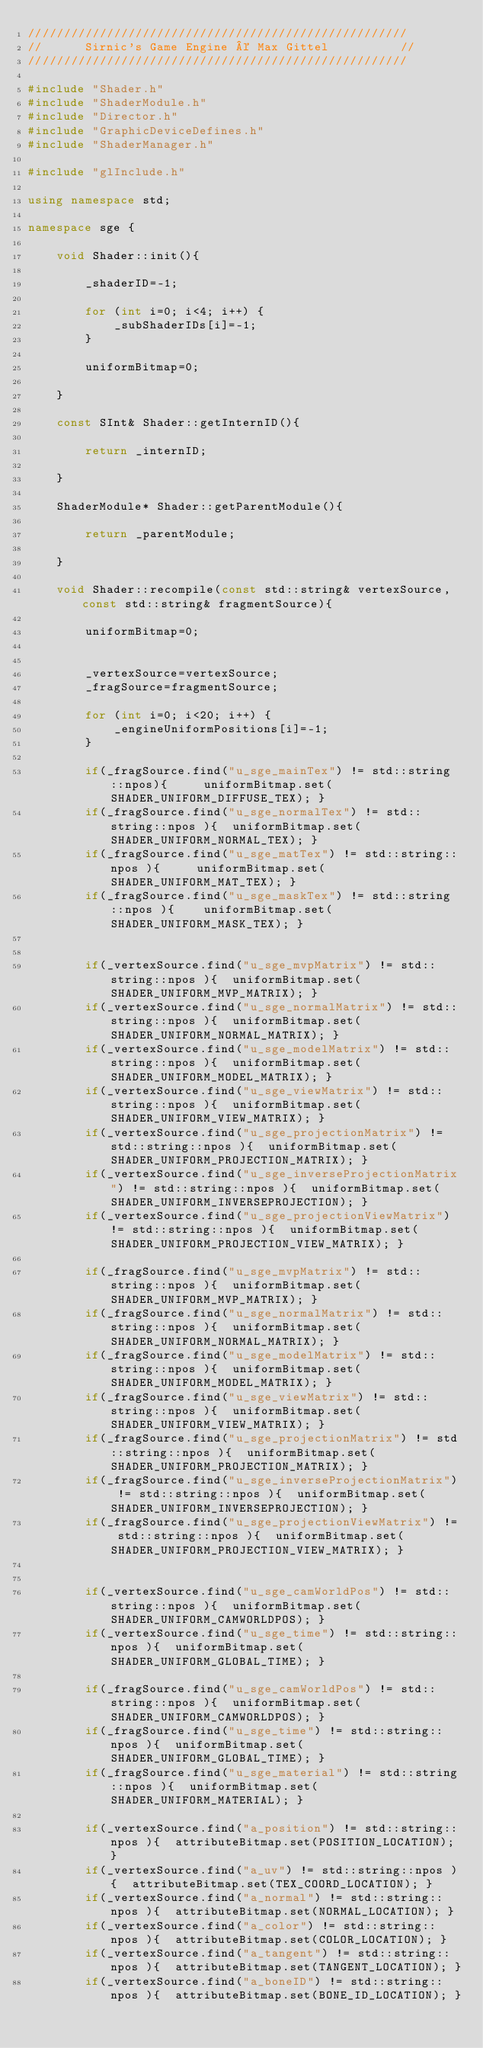<code> <loc_0><loc_0><loc_500><loc_500><_C++_>/////////////////////////////////////////////////////
//      Sirnic's Game Engine © Max Gittel          //
/////////////////////////////////////////////////////

#include "Shader.h"
#include "ShaderModule.h"
#include "Director.h"
#include "GraphicDeviceDefines.h"
#include "ShaderManager.h"

#include "glInclude.h"

using namespace std;

namespace sge {
    
    void Shader::init(){
    
        _shaderID=-1;
       
        for (int i=0; i<4; i++) {
            _subShaderIDs[i]=-1;
        }
        
        uniformBitmap=0;

    }
    
    const SInt& Shader::getInternID(){
    
        return _internID;
    
    }
    
    ShaderModule* Shader::getParentModule(){
    
        return _parentModule;
    
    }
    
    void Shader::recompile(const std::string& vertexSource, const std::string& fragmentSource){
    
        uniformBitmap=0;
        
        
        _vertexSource=vertexSource;
        _fragSource=fragmentSource;
        
        for (int i=0; i<20; i++) {
            _engineUniformPositions[i]=-1;
        }
        
        if(_fragSource.find("u_sge_mainTex") != std::string::npos){     uniformBitmap.set(SHADER_UNIFORM_DIFFUSE_TEX); }
        if(_fragSource.find("u_sge_normalTex") != std::string::npos ){  uniformBitmap.set(SHADER_UNIFORM_NORMAL_TEX); }
        if(_fragSource.find("u_sge_matTex") != std::string::npos ){     uniformBitmap.set(SHADER_UNIFORM_MAT_TEX); }
        if(_fragSource.find("u_sge_maskTex") != std::string::npos ){    uniformBitmap.set(SHADER_UNIFORM_MASK_TEX); }
        
        
        if(_vertexSource.find("u_sge_mvpMatrix") != std::string::npos ){  uniformBitmap.set(SHADER_UNIFORM_MVP_MATRIX); }
        if(_vertexSource.find("u_sge_normalMatrix") != std::string::npos ){  uniformBitmap.set(SHADER_UNIFORM_NORMAL_MATRIX); }
        if(_vertexSource.find("u_sge_modelMatrix") != std::string::npos ){  uniformBitmap.set(SHADER_UNIFORM_MODEL_MATRIX); }
        if(_vertexSource.find("u_sge_viewMatrix") != std::string::npos ){  uniformBitmap.set(SHADER_UNIFORM_VIEW_MATRIX); }
        if(_vertexSource.find("u_sge_projectionMatrix") != std::string::npos ){  uniformBitmap.set(SHADER_UNIFORM_PROJECTION_MATRIX); }
        if(_vertexSource.find("u_sge_inverseProjectionMatrix") != std::string::npos ){  uniformBitmap.set(SHADER_UNIFORM_INVERSEPROJECTION); }
        if(_vertexSource.find("u_sge_projectionViewMatrix") != std::string::npos ){  uniformBitmap.set(SHADER_UNIFORM_PROJECTION_VIEW_MATRIX); }
        
        if(_fragSource.find("u_sge_mvpMatrix") != std::string::npos ){  uniformBitmap.set(SHADER_UNIFORM_MVP_MATRIX); }
        if(_fragSource.find("u_sge_normalMatrix") != std::string::npos ){  uniformBitmap.set(SHADER_UNIFORM_NORMAL_MATRIX); }
        if(_fragSource.find("u_sge_modelMatrix") != std::string::npos ){  uniformBitmap.set(SHADER_UNIFORM_MODEL_MATRIX); }
        if(_fragSource.find("u_sge_viewMatrix") != std::string::npos ){  uniformBitmap.set(SHADER_UNIFORM_VIEW_MATRIX); }
        if(_fragSource.find("u_sge_projectionMatrix") != std::string::npos ){  uniformBitmap.set(SHADER_UNIFORM_PROJECTION_MATRIX); }
        if(_fragSource.find("u_sge_inverseProjectionMatrix") != std::string::npos ){  uniformBitmap.set(SHADER_UNIFORM_INVERSEPROJECTION); }
        if(_fragSource.find("u_sge_projectionViewMatrix") != std::string::npos ){  uniformBitmap.set(SHADER_UNIFORM_PROJECTION_VIEW_MATRIX); }
        
        
        if(_vertexSource.find("u_sge_camWorldPos") != std::string::npos ){  uniformBitmap.set(SHADER_UNIFORM_CAMWORLDPOS); }
        if(_vertexSource.find("u_sge_time") != std::string::npos ){  uniformBitmap.set(SHADER_UNIFORM_GLOBAL_TIME); }
        
        if(_fragSource.find("u_sge_camWorldPos") != std::string::npos ){  uniformBitmap.set(SHADER_UNIFORM_CAMWORLDPOS); }
        if(_fragSource.find("u_sge_time") != std::string::npos ){  uniformBitmap.set(SHADER_UNIFORM_GLOBAL_TIME); }
        if(_fragSource.find("u_sge_material") != std::string::npos ){  uniformBitmap.set(SHADER_UNIFORM_MATERIAL); }
        
        if(_vertexSource.find("a_position") != std::string::npos ){  attributeBitmap.set(POSITION_LOCATION); }
        if(_vertexSource.find("a_uv") != std::string::npos ){  attributeBitmap.set(TEX_COORD_LOCATION); }
        if(_vertexSource.find("a_normal") != std::string::npos ){  attributeBitmap.set(NORMAL_LOCATION); }
        if(_vertexSource.find("a_color") != std::string::npos ){  attributeBitmap.set(COLOR_LOCATION); }
        if(_vertexSource.find("a_tangent") != std::string::npos ){  attributeBitmap.set(TANGENT_LOCATION); }
        if(_vertexSource.find("a_boneID") != std::string::npos ){  attributeBitmap.set(BONE_ID_LOCATION); }</code> 